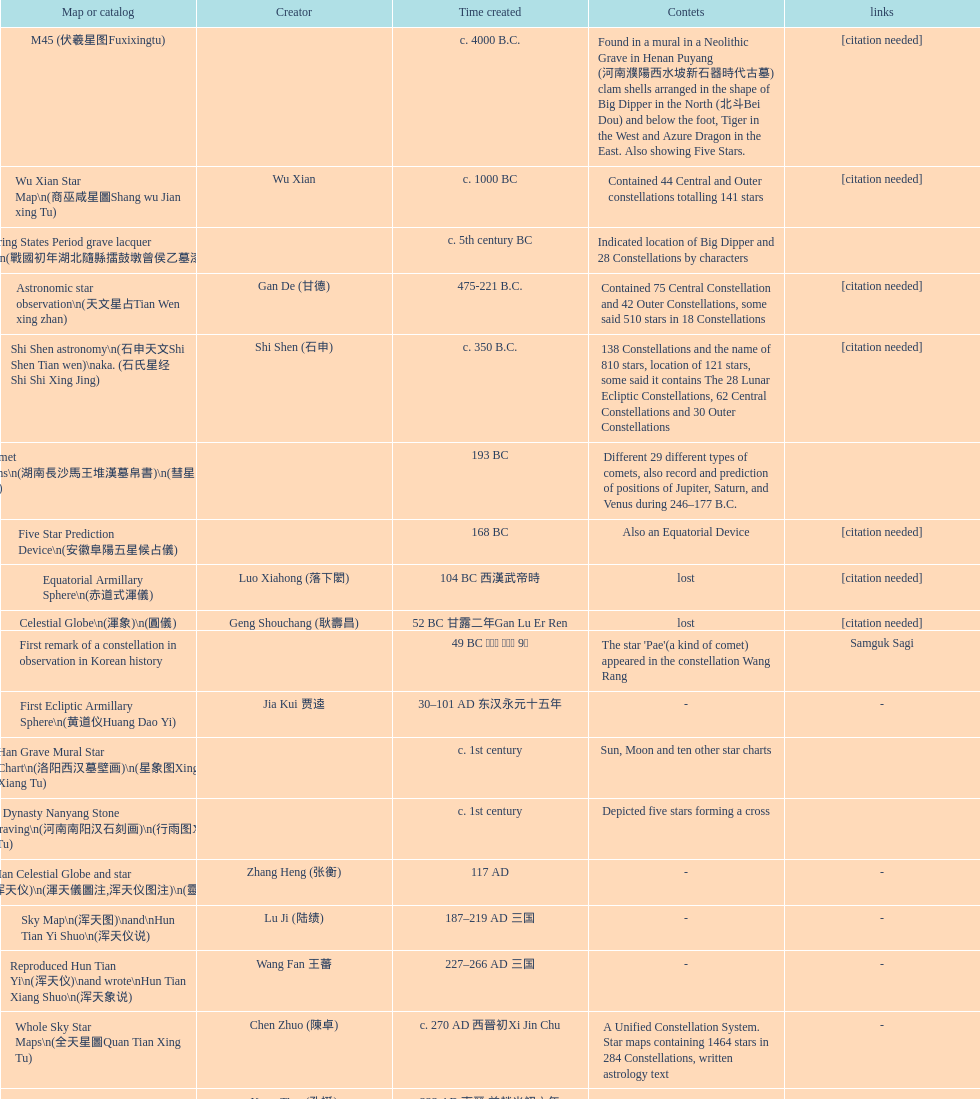Which map or catalog was most recently created? Sky in Google Earth KML. 